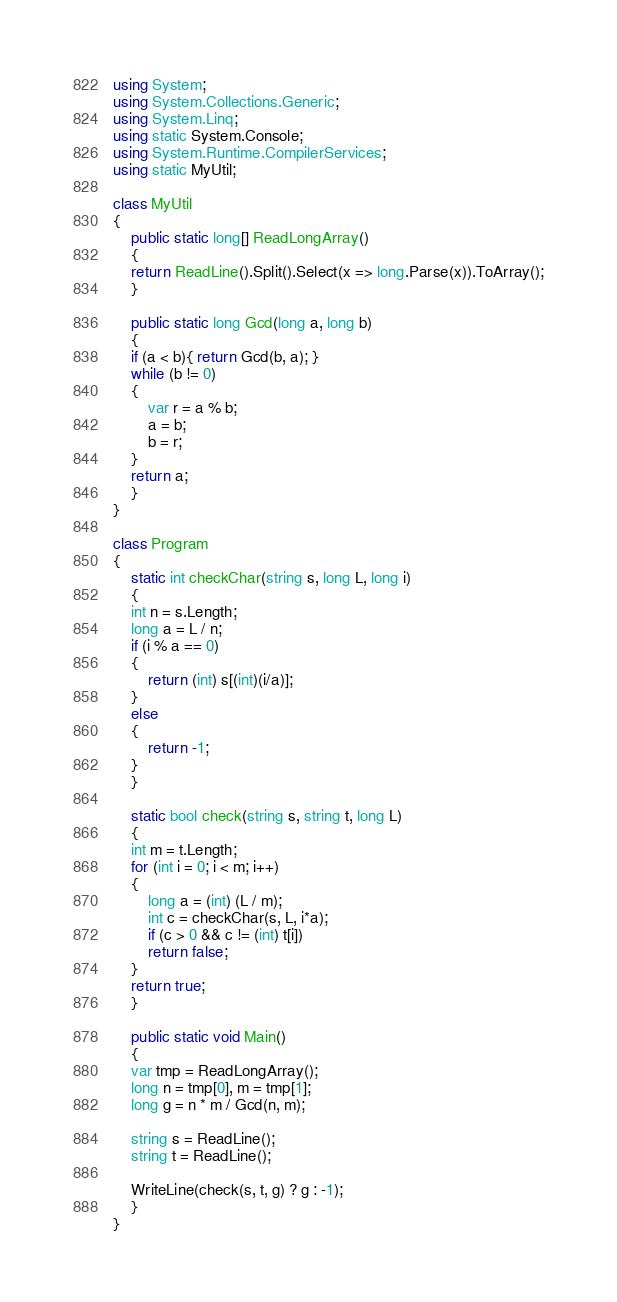<code> <loc_0><loc_0><loc_500><loc_500><_C#_>using System;
using System.Collections.Generic;
using System.Linq;
using static System.Console;
using System.Runtime.CompilerServices;
using static MyUtil;

class MyUtil
{
    public static long[] ReadLongArray()
    {
	return ReadLine().Split().Select(x => long.Parse(x)).ToArray();
    }

    public static long Gcd(long a, long b)
    {
	if (a < b){ return Gcd(b, a); }
	while (b != 0)
	{
	    var r = a % b;
	    a = b;
	    b = r;
	}
	return a;
    }
}

class Program
{
    static int checkChar(string s, long L, long i)
    {
	int n = s.Length;
	long a = L / n;
	if (i % a == 0)
	{
	    return (int) s[(int)(i/a)];
	}
	else
	{
	    return -1;
	}
    }

    static bool check(string s, string t, long L)
    {
	int m = t.Length;
	for (int i = 0; i < m; i++)
	{
	    long a = (int) (L / m);
	    int c = checkChar(s, L, i*a);
	    if (c > 0 && c != (int) t[i])
		return false;
	}
	return true;
    }
    
    public static void Main()
    {
	var tmp = ReadLongArray();
	long n = tmp[0], m = tmp[1];
	long g = n * m / Gcd(n, m);

	string s = ReadLine();
	string t = ReadLine();

	WriteLine(check(s, t, g) ? g : -1);
    }
}
</code> 